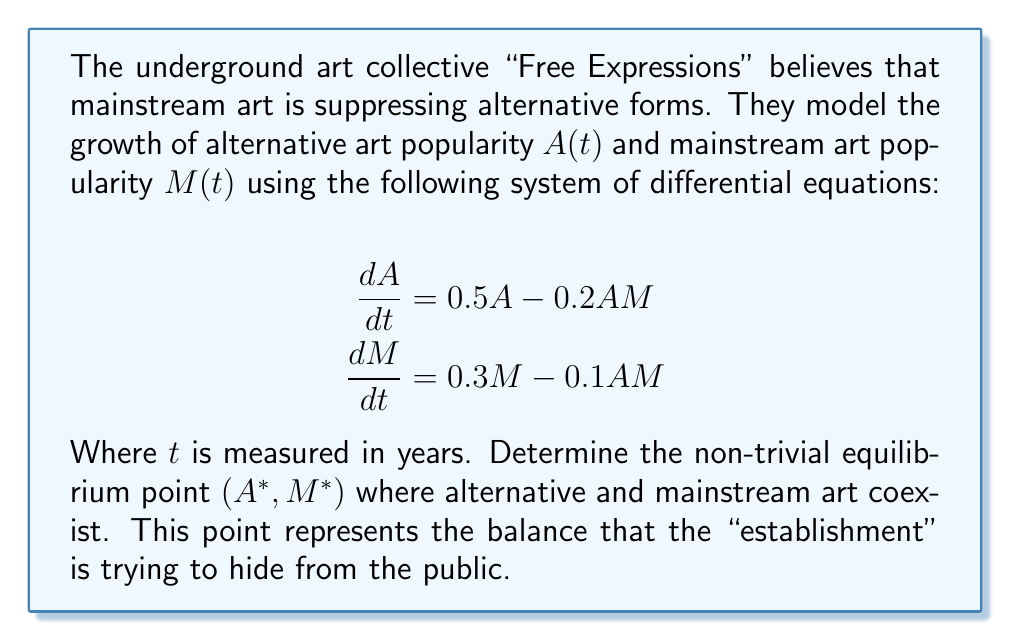What is the answer to this math problem? To find the equilibrium point, we need to set both derivatives to zero and solve the resulting system of equations:

1) Set $\frac{dA}{dt} = 0$ and $\frac{dM}{dt} = 0$:
   $$0 = 0.5A - 0.2AM$$
   $$0 = 0.3M - 0.1AM$$

2) From the first equation:
   $$0.5A - 0.2AM = 0$$
   $$A(0.5 - 0.2M) = 0$$
   Either $A = 0$ or $0.5 - 0.2M = 0$

3) We're looking for the non-trivial solution, so:
   $$0.5 - 0.2M = 0$$
   $$0.5 = 0.2M$$
   $$M^* = 2.5$$

4) Substitute this into the second equation:
   $$0 = 0.3M - 0.1AM$$
   $$0 = 0.3(2.5) - 0.1A(2.5)$$
   $$0 = 0.75 - 0.25A$$
   $$0.25A = 0.75$$
   $$A^* = 3$$

5) Therefore, the non-trivial equilibrium point is $(A^*, M^*) = (3, 2.5)$
Answer: $(3, 2.5)$ 